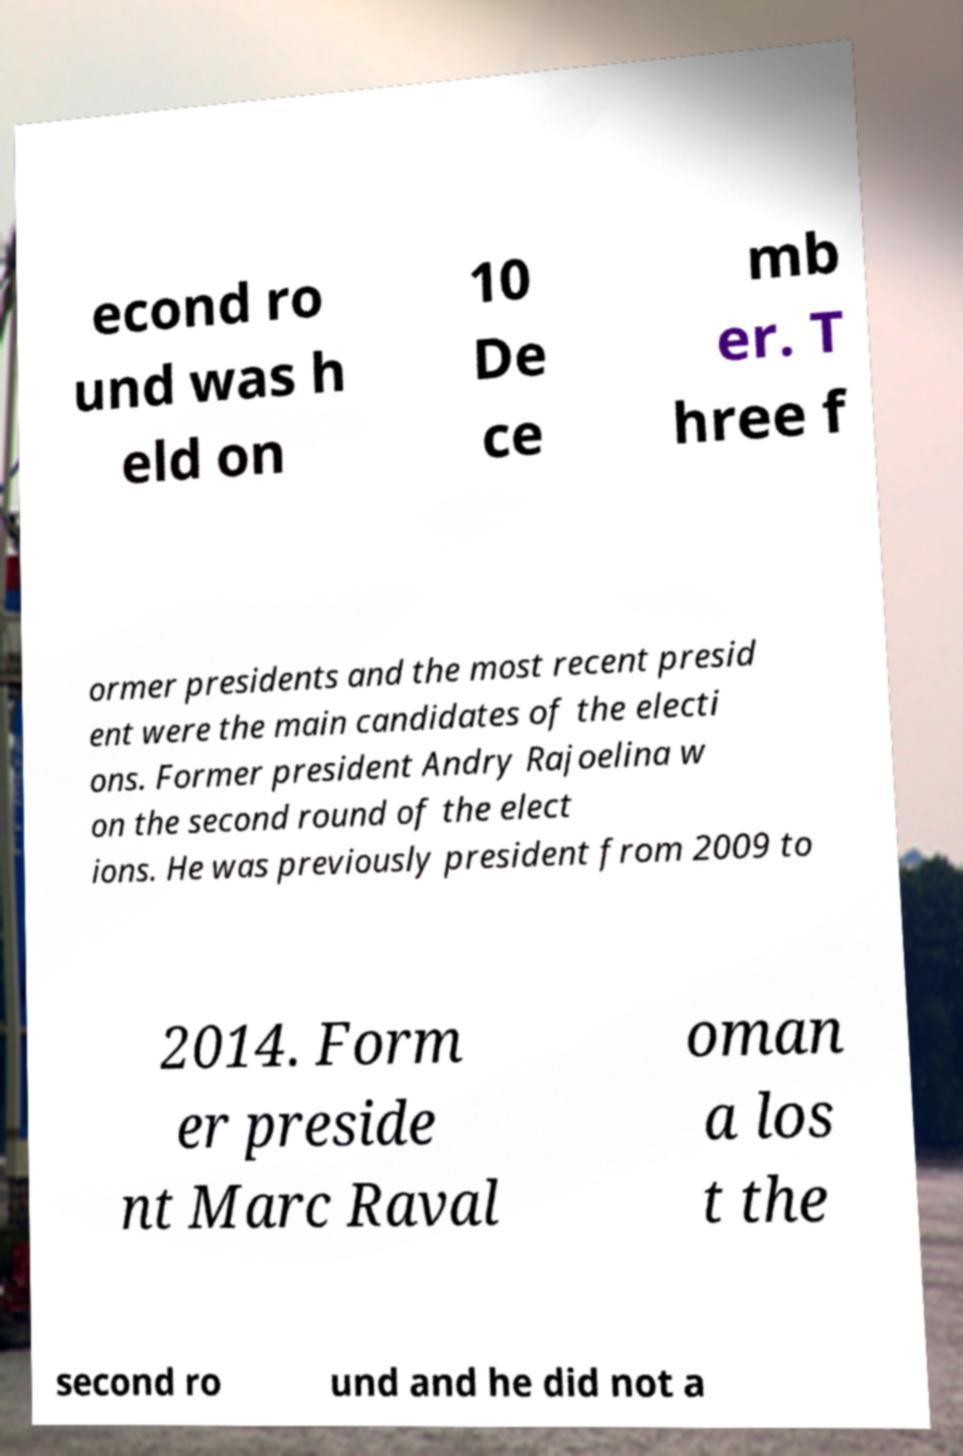Could you assist in decoding the text presented in this image and type it out clearly? econd ro und was h eld on 10 De ce mb er. T hree f ormer presidents and the most recent presid ent were the main candidates of the electi ons. Former president Andry Rajoelina w on the second round of the elect ions. He was previously president from 2009 to 2014. Form er preside nt Marc Raval oman a los t the second ro und and he did not a 